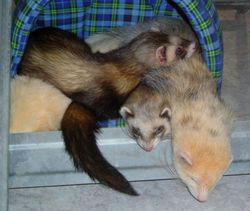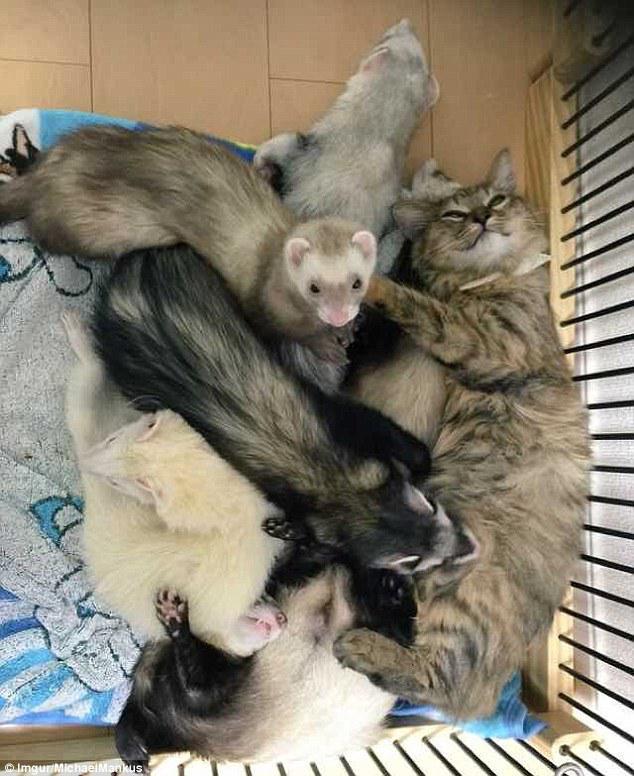The first image is the image on the left, the second image is the image on the right. Considering the images on both sides, is "All images show ferrets with their faces aligned together, and at least one image contains exactly three ferrets." valid? Answer yes or no. No. 